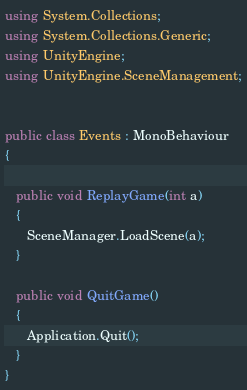Convert code to text. <code><loc_0><loc_0><loc_500><loc_500><_C#_>using System.Collections;
using System.Collections.Generic;
using UnityEngine;
using UnityEngine.SceneManagement;


public class Events : MonoBehaviour
{
   
   public void ReplayGame(int a)
   {
      SceneManager.LoadScene(a);
   }

   public void QuitGame()
   {
      Application.Quit();
   }
}
</code> 